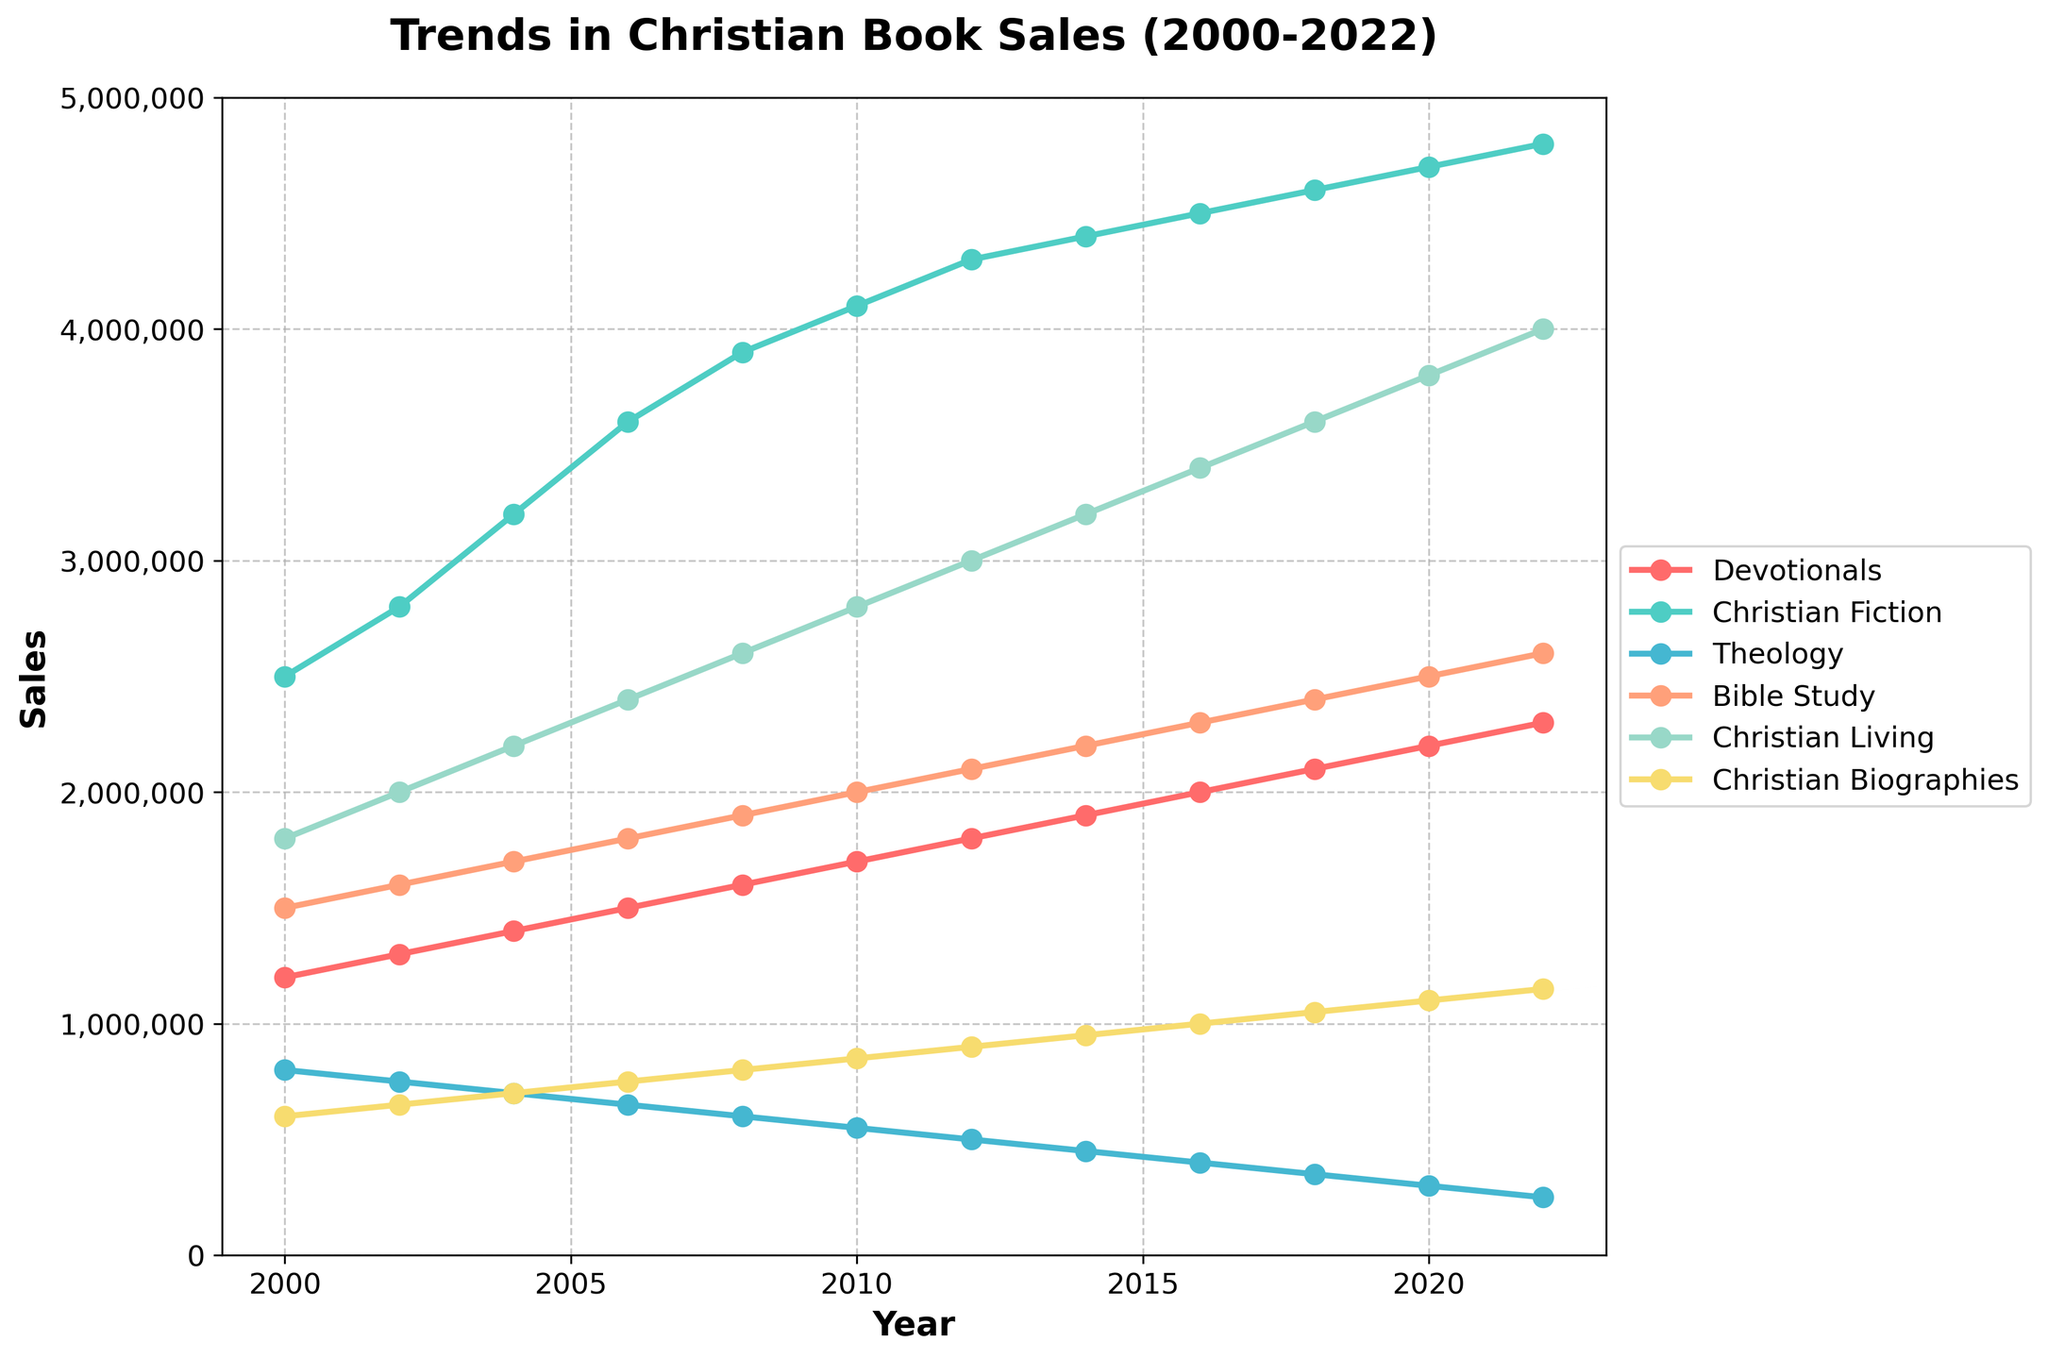How many more Christian Fiction books were sold in 2022 compared to 2000? First, note the sales of Christian Fiction books in 2022 (4,800,000) and in 2000 (2,500,000). Subtract the sales in 2000 from the sales in 2022: 4,800,000 - 2,500,000 = 2,300,000
Answer: 2,300,000 Which genre had the highest sales in 2022? Look at the data points for 2022 for each genre. Christian Fiction has the highest sales at 4,800,000
Answer: Christian Fiction How did the sales of Bible Study books change from 2006 to 2012? Note the sales of Bible Study books in 2006 (1,800,000) and in 2012 (2,100,000). Subtract the sales in 2006 from the sales in 2012: 2,100,000 - 1,800,000 = 300,000
Answer: Increased by 300,000 Compare the sales trends of Christian Living and Christian Biographies from 2000 to 2022. Which genre had a faster growth rate? Calculate the increase for both genres over the observed period. For Christian Living: 4,000,000 (2022) - 1,800,000 (2000) = 2,200,000. For Christian Biographies: 1,150,000 (2022) - 600,000 (2000) = 550,000. Christian Living had a larger increase, suggesting a faster growth rate.
Answer: Christian Living In what year did devotionals surpass 2,000,000 in sales, and how much did they sell that year? Identify the year when Devotionals first surpass 2,000,000. This occurred in 2016 with sales of 2,000,000
Answer: 2016, 2,000,000 Among the genres, which showed a declining trend in sales over the period from 2000 to 2022? By observing the trends, Theology is the only genre that shows declining sales, from 800,000 in 2000 to 250,000 in 2022
Answer: Theology What is the combined sales of Devotionals and Bible Study books in 2020? Add the sales for Devotionals (2,200,000) and Bible Study (2,500,000) in 2020: 2,200,000 + 2,500,000 = 4,700,000
Answer: 4,700,000 Which genre had the smallest sales in 2020 and what were the sales? Identify the genre with the smallest sales in 2020. Theology had the smallest sales at 300,000
Answer: Theology, 300,000 By how much did Christian Biographies sales increase from 2010 to 2022? Calculate the difference in sales of Christian Biographies from 2010 (850,000) to 2022 (1,150,000): 1,150,000 - 850,000 = 300,000
Answer: 300,000 When did Christian Fiction reach 4,700,000 in sales, and what was the sales amount at that point? Look at the trend and identify the year Christian Fiction reached 4,700,000 in sales. This happened in 2020
Answer: 2020, 4,700,000 